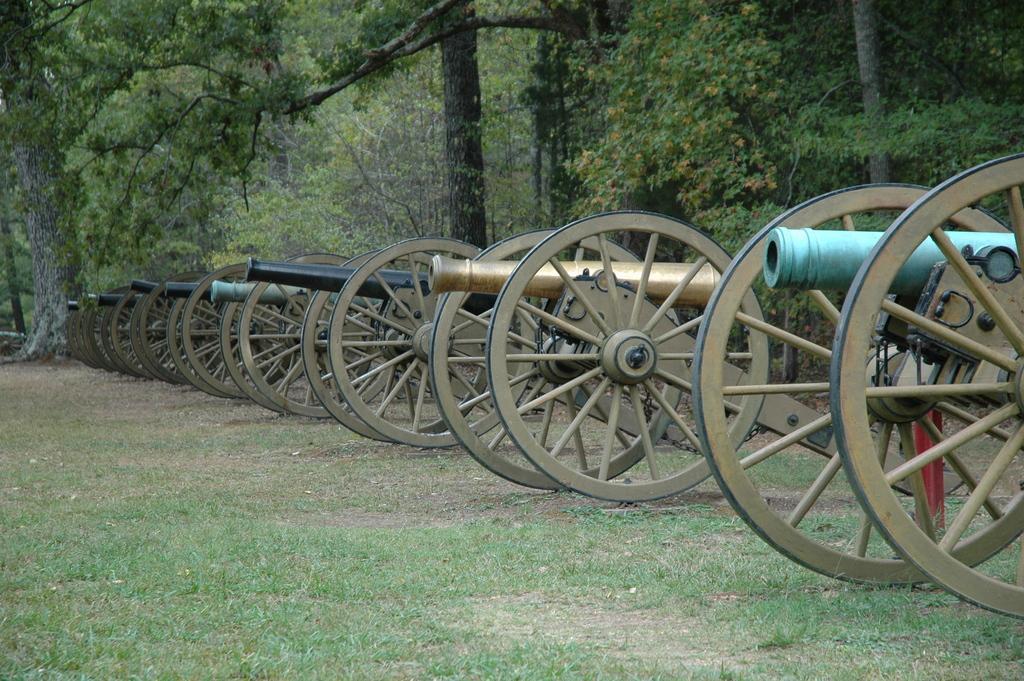Can you describe this image briefly? In this picture I can see a number of cannons. I can see green grass. I can see trees in the background. 